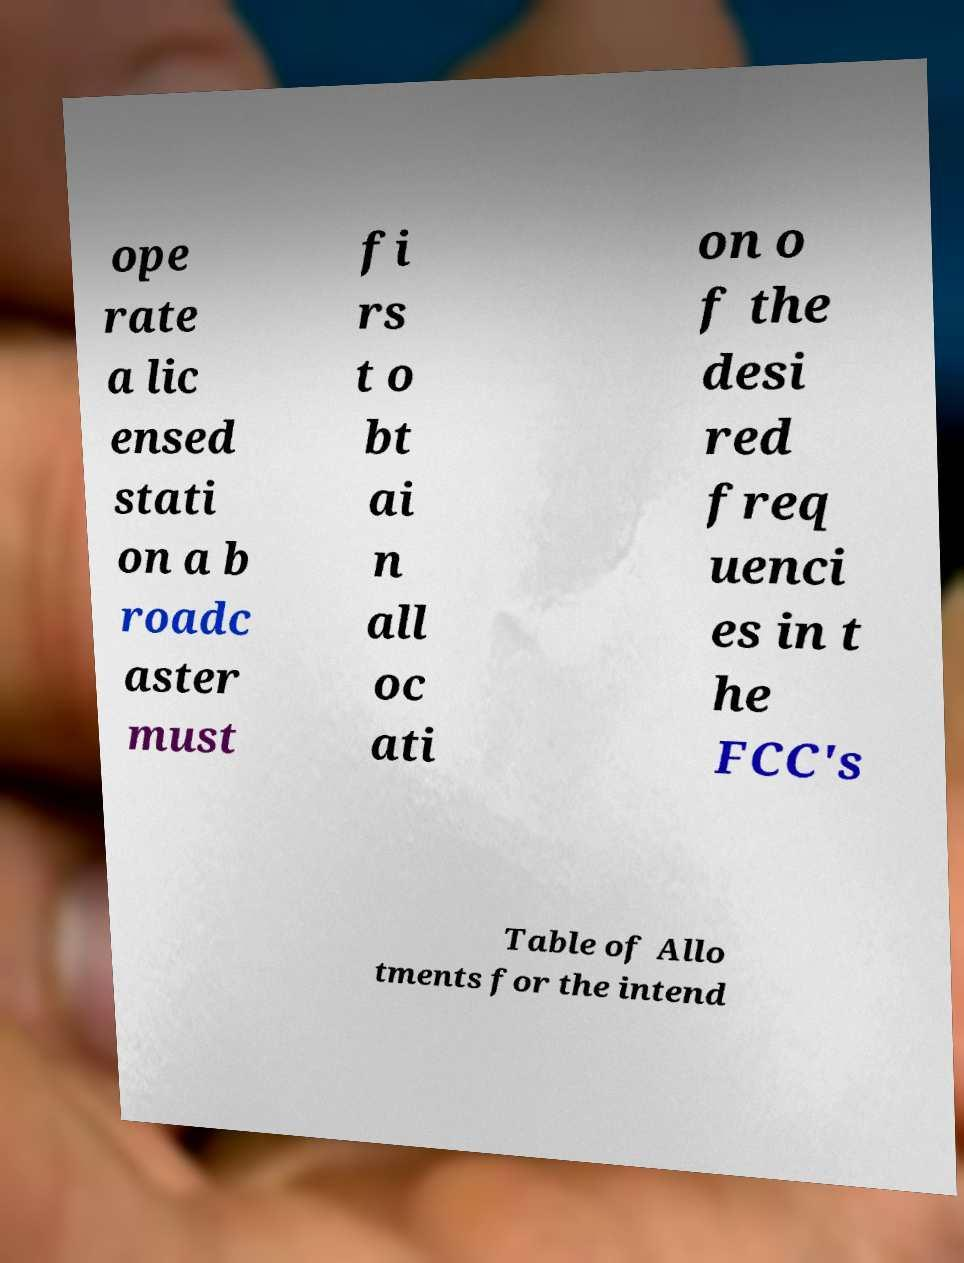Can you read and provide the text displayed in the image?This photo seems to have some interesting text. Can you extract and type it out for me? ope rate a lic ensed stati on a b roadc aster must fi rs t o bt ai n all oc ati on o f the desi red freq uenci es in t he FCC's Table of Allo tments for the intend 